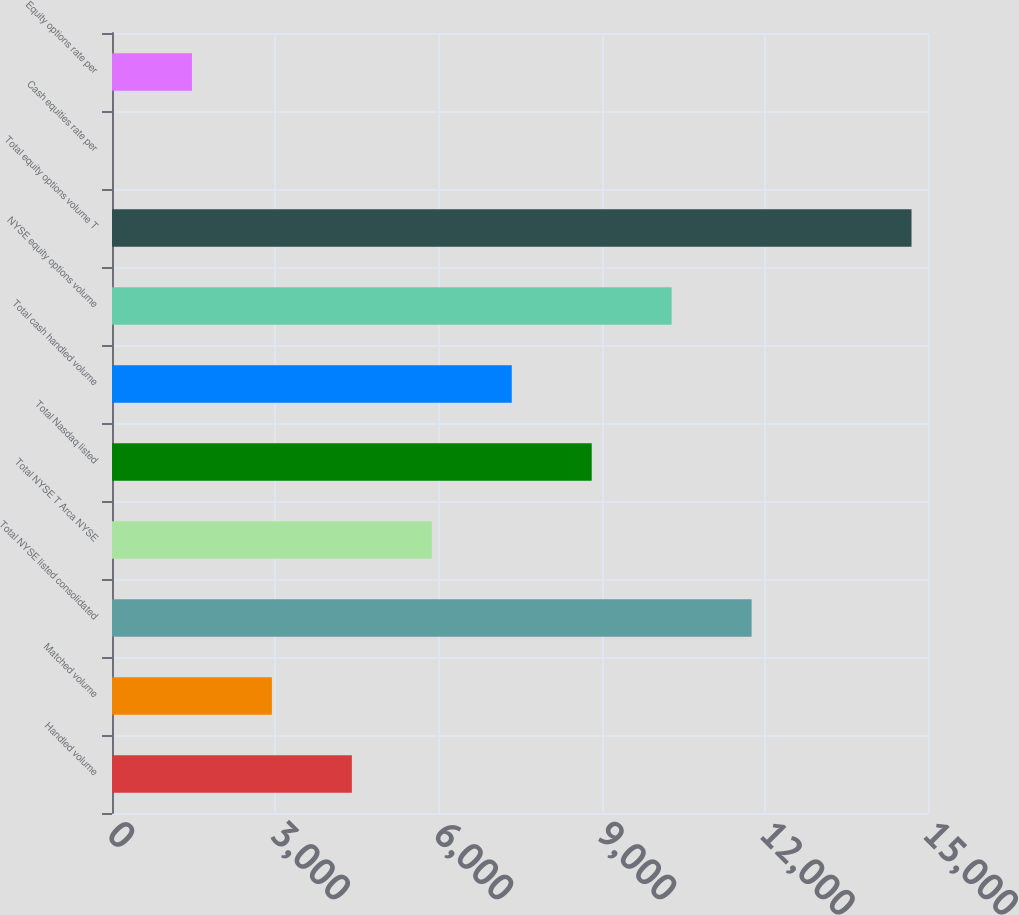Convert chart to OTSL. <chart><loc_0><loc_0><loc_500><loc_500><bar_chart><fcel>Handled volume<fcel>Matched volume<fcel>Total NYSE listed consolidated<fcel>Total NYSE T Arca NYSE<fcel>Total Nasdaq listed<fcel>Total cash handled volume<fcel>NYSE equity options volume<fcel>Total equity options volume T<fcel>Cash equities rate per<fcel>Equity options rate per<nl><fcel>4409.15<fcel>2939.45<fcel>11757.6<fcel>5878.84<fcel>8818.23<fcel>7348.53<fcel>10287.9<fcel>14697<fcel>0.05<fcel>1469.75<nl></chart> 